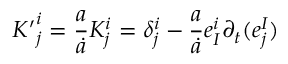Convert formula to latex. <formula><loc_0><loc_0><loc_500><loc_500>{ K ^ { \prime } } _ { j } ^ { i } = { \frac { a } { \dot { a } } } K _ { j } ^ { i } = \delta _ { j } ^ { i } - { \frac { a } { \dot { a } } } e _ { I } ^ { i } \partial _ { t } ( e _ { j } ^ { I } )</formula> 